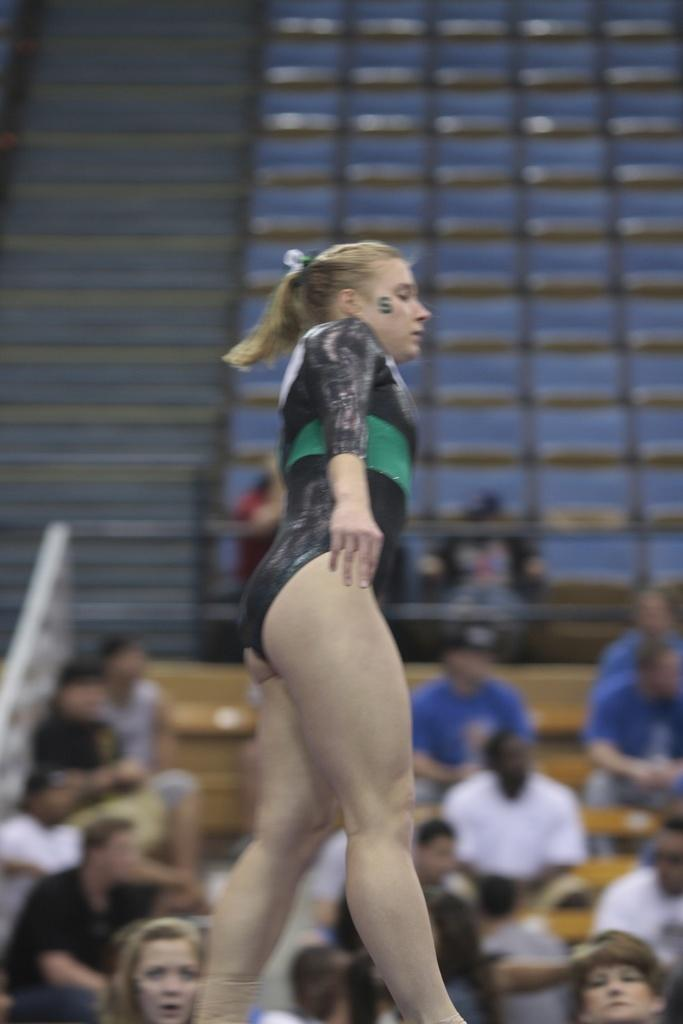Who is the main subject in the image? There is a woman in the image. What is the woman doing in the image? The woman appears to be performing gymnastics. Can you describe the setting of the image? The background suggests a stadium setting, with many people in the background. What type of car can be seen driving through the stadium in the image? There is no car present in the image; it features a woman performing gymnastics in a stadium setting. Can you describe the ant that is crawling on the woman's leg in the image? There is no ant present in the image; it only shows the woman performing gymnastics. 